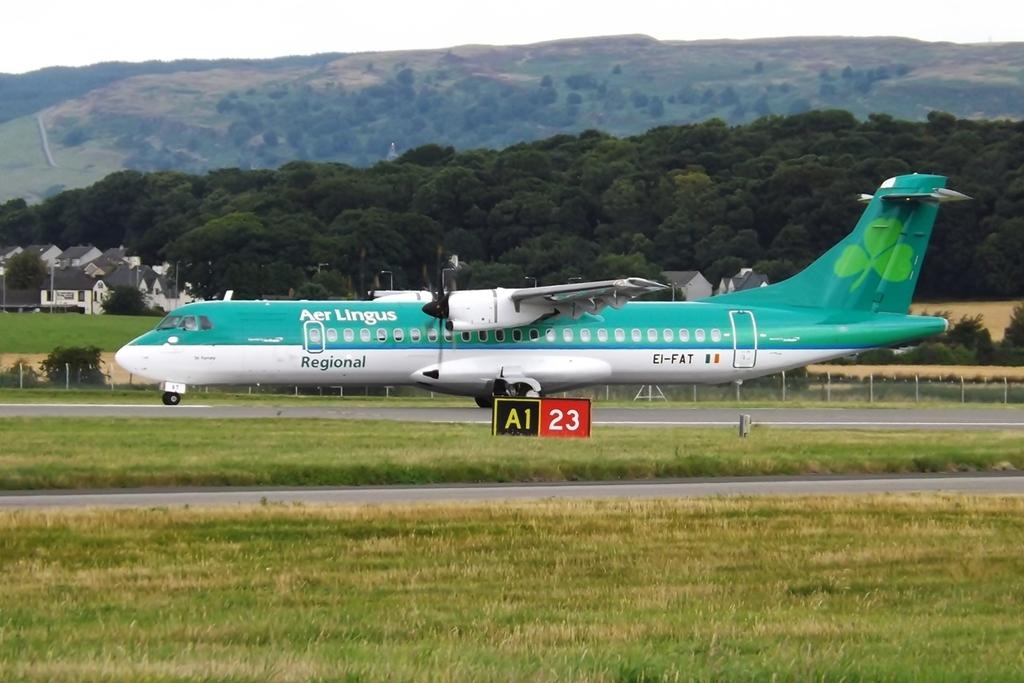<image>
Offer a succinct explanation of the picture presented. an air lingus airplane that is green and white 